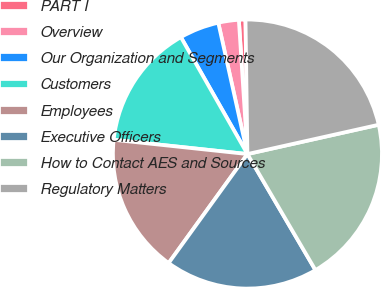<chart> <loc_0><loc_0><loc_500><loc_500><pie_chart><fcel>PART I<fcel>Overview<fcel>Our Organization and Segments<fcel>Customers<fcel>Employees<fcel>Executive Officers<fcel>How to Contact AES and Sources<fcel>Regulatory Matters<nl><fcel>0.79%<fcel>2.46%<fcel>4.76%<fcel>15.07%<fcel>16.73%<fcel>18.4%<fcel>20.06%<fcel>21.73%<nl></chart> 